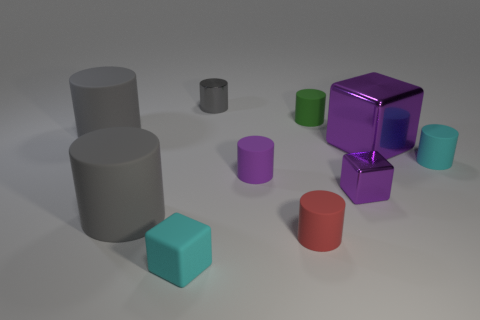What material is the gray cylinder in front of the tiny cyan object to the right of the tiny gray cylinder?
Give a very brief answer. Rubber. Is there a gray cylinder made of the same material as the tiny purple block?
Your answer should be very brief. Yes. Is there a purple metallic block that is behind the shiny block that is in front of the cyan cylinder?
Your response must be concise. Yes. There is a cylinder that is behind the tiny green matte cylinder; what material is it?
Offer a terse response. Metal. Is the large shiny thing the same shape as the small purple shiny thing?
Offer a very short reply. Yes. There is a small cube that is behind the tiny cylinder in front of the small shiny object that is on the right side of the green matte cylinder; what is its color?
Offer a very short reply. Purple. How many other matte objects have the same shape as the large purple thing?
Offer a very short reply. 1. There is a cyan object that is right of the metallic thing left of the green rubber cylinder; how big is it?
Your answer should be very brief. Small. Do the rubber cube and the purple matte cylinder have the same size?
Provide a short and direct response. Yes. Are there any rubber things to the right of the gray thing on the right side of the small cyan rubber thing left of the metallic cylinder?
Keep it short and to the point. Yes. 